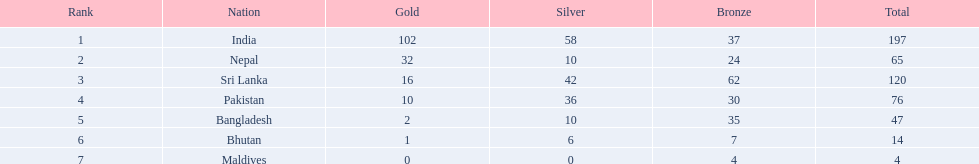What was the only nation to win less than 10 medals total? Maldives. 